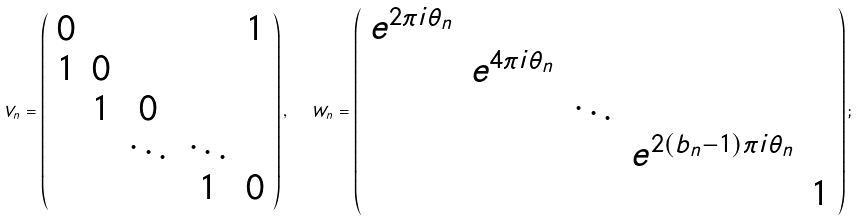<formula> <loc_0><loc_0><loc_500><loc_500>V _ { n } = \left ( \begin{array} { c c c c c } 0 & & & & 1 \\ 1 & 0 & & & \\ & 1 & 0 & & \\ & & \ddots & \ddots & \\ & & & 1 & 0 \end{array} \right ) , \ \ W _ { n } = \left ( \begin{array} { c c c c c } e ^ { 2 \pi i \theta _ { n } } & & & & \\ & e ^ { 4 \pi i \theta _ { n } } & & & \\ & & \ddots & & \\ & & & e ^ { 2 ( b _ { n } - 1 ) \pi i \theta _ { n } } & \\ & & & & 1 \end{array} \right ) ;</formula> 